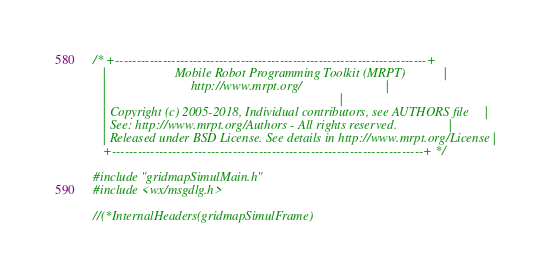<code> <loc_0><loc_0><loc_500><loc_500><_C++_>/* +------------------------------------------------------------------------+
   |                     Mobile Robot Programming Toolkit (MRPT)            |
   |                          http://www.mrpt.org/                          |
   |                                                                        |
   | Copyright (c) 2005-2018, Individual contributors, see AUTHORS file     |
   | See: http://www.mrpt.org/Authors - All rights reserved.                |
   | Released under BSD License. See details in http://www.mrpt.org/License |
   +------------------------------------------------------------------------+ */

#include "gridmapSimulMain.h"
#include <wx/msgdlg.h>

//(*InternalHeaders(gridmapSimulFrame)</code> 